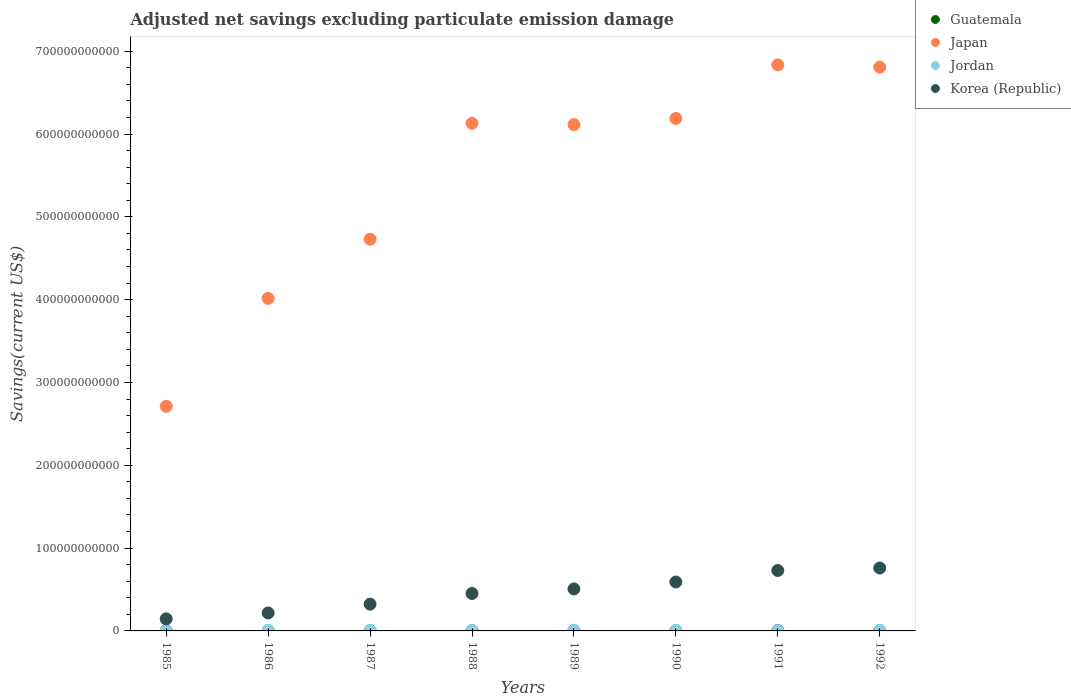Is the number of dotlines equal to the number of legend labels?
Your answer should be compact. Yes. What is the adjusted net savings in Guatemala in 1985?
Give a very brief answer. 2.18e+08. Across all years, what is the maximum adjusted net savings in Japan?
Keep it short and to the point. 6.84e+11. Across all years, what is the minimum adjusted net savings in Jordan?
Make the answer very short. 3.53e+08. What is the total adjusted net savings in Guatemala in the graph?
Your answer should be compact. 1.86e+09. What is the difference between the adjusted net savings in Japan in 1985 and that in 1990?
Give a very brief answer. -3.48e+11. What is the difference between the adjusted net savings in Guatemala in 1985 and the adjusted net savings in Jordan in 1986?
Offer a terse response. -4.72e+08. What is the average adjusted net savings in Japan per year?
Your response must be concise. 5.44e+11. In the year 1989, what is the difference between the adjusted net savings in Jordan and adjusted net savings in Guatemala?
Keep it short and to the point. 6.86e+08. In how many years, is the adjusted net savings in Korea (Republic) greater than 280000000000 US$?
Your answer should be very brief. 0. What is the ratio of the adjusted net savings in Jordan in 1986 to that in 1989?
Provide a short and direct response. 0.73. Is the difference between the adjusted net savings in Jordan in 1985 and 1988 greater than the difference between the adjusted net savings in Guatemala in 1985 and 1988?
Your answer should be compact. No. What is the difference between the highest and the second highest adjusted net savings in Korea (Republic)?
Give a very brief answer. 3.00e+09. What is the difference between the highest and the lowest adjusted net savings in Guatemala?
Your response must be concise. 3.24e+08. Is it the case that in every year, the sum of the adjusted net savings in Japan and adjusted net savings in Guatemala  is greater than the sum of adjusted net savings in Korea (Republic) and adjusted net savings in Jordan?
Offer a terse response. Yes. Does the adjusted net savings in Japan monotonically increase over the years?
Your answer should be very brief. No. Is the adjusted net savings in Korea (Republic) strictly greater than the adjusted net savings in Jordan over the years?
Your response must be concise. Yes. Is the adjusted net savings in Korea (Republic) strictly less than the adjusted net savings in Jordan over the years?
Make the answer very short. No. How many years are there in the graph?
Your answer should be very brief. 8. What is the difference between two consecutive major ticks on the Y-axis?
Give a very brief answer. 1.00e+11. Are the values on the major ticks of Y-axis written in scientific E-notation?
Provide a succinct answer. No. Does the graph contain grids?
Make the answer very short. No. How are the legend labels stacked?
Your answer should be very brief. Vertical. What is the title of the graph?
Ensure brevity in your answer.  Adjusted net savings excluding particulate emission damage. What is the label or title of the Y-axis?
Give a very brief answer. Savings(current US$). What is the Savings(current US$) of Guatemala in 1985?
Provide a succinct answer. 2.18e+08. What is the Savings(current US$) of Japan in 1985?
Your answer should be very brief. 2.71e+11. What is the Savings(current US$) in Jordan in 1985?
Keep it short and to the point. 4.20e+08. What is the Savings(current US$) in Korea (Republic) in 1985?
Provide a short and direct response. 1.46e+1. What is the Savings(current US$) in Guatemala in 1986?
Provide a short and direct response. 2.37e+08. What is the Savings(current US$) in Japan in 1986?
Make the answer very short. 4.02e+11. What is the Savings(current US$) of Jordan in 1986?
Offer a very short reply. 6.90e+08. What is the Savings(current US$) in Korea (Republic) in 1986?
Your answer should be very brief. 2.17e+1. What is the Savings(current US$) of Guatemala in 1987?
Provide a short and direct response. 7.49e+07. What is the Savings(current US$) in Japan in 1987?
Your response must be concise. 4.73e+11. What is the Savings(current US$) of Jordan in 1987?
Provide a short and direct response. 5.22e+08. What is the Savings(current US$) of Korea (Republic) in 1987?
Your answer should be compact. 3.23e+1. What is the Savings(current US$) of Guatemala in 1988?
Ensure brevity in your answer.  1.57e+08. What is the Savings(current US$) in Japan in 1988?
Keep it short and to the point. 6.13e+11. What is the Savings(current US$) in Jordan in 1988?
Make the answer very short. 7.16e+08. What is the Savings(current US$) in Korea (Republic) in 1988?
Your answer should be compact. 4.52e+1. What is the Savings(current US$) of Guatemala in 1989?
Keep it short and to the point. 2.54e+08. What is the Savings(current US$) of Japan in 1989?
Make the answer very short. 6.11e+11. What is the Savings(current US$) in Jordan in 1989?
Your answer should be compact. 9.40e+08. What is the Savings(current US$) of Korea (Republic) in 1989?
Provide a short and direct response. 5.07e+1. What is the Savings(current US$) in Guatemala in 1990?
Give a very brief answer. 1.51e+08. What is the Savings(current US$) in Japan in 1990?
Make the answer very short. 6.19e+11. What is the Savings(current US$) in Jordan in 1990?
Offer a terse response. 6.75e+08. What is the Savings(current US$) in Korea (Republic) in 1990?
Your answer should be compact. 5.91e+1. What is the Savings(current US$) in Guatemala in 1991?
Keep it short and to the point. 3.66e+08. What is the Savings(current US$) in Japan in 1991?
Provide a succinct answer. 6.84e+11. What is the Savings(current US$) in Jordan in 1991?
Offer a very short reply. 3.53e+08. What is the Savings(current US$) of Korea (Republic) in 1991?
Your answer should be compact. 7.30e+1. What is the Savings(current US$) of Guatemala in 1992?
Your answer should be very brief. 3.99e+08. What is the Savings(current US$) of Japan in 1992?
Offer a terse response. 6.81e+11. What is the Savings(current US$) in Jordan in 1992?
Keep it short and to the point. 6.44e+08. What is the Savings(current US$) of Korea (Republic) in 1992?
Your answer should be compact. 7.60e+1. Across all years, what is the maximum Savings(current US$) of Guatemala?
Your answer should be very brief. 3.99e+08. Across all years, what is the maximum Savings(current US$) in Japan?
Your answer should be very brief. 6.84e+11. Across all years, what is the maximum Savings(current US$) in Jordan?
Provide a succinct answer. 9.40e+08. Across all years, what is the maximum Savings(current US$) in Korea (Republic)?
Keep it short and to the point. 7.60e+1. Across all years, what is the minimum Savings(current US$) in Guatemala?
Provide a short and direct response. 7.49e+07. Across all years, what is the minimum Savings(current US$) in Japan?
Give a very brief answer. 2.71e+11. Across all years, what is the minimum Savings(current US$) in Jordan?
Make the answer very short. 3.53e+08. Across all years, what is the minimum Savings(current US$) in Korea (Republic)?
Make the answer very short. 1.46e+1. What is the total Savings(current US$) of Guatemala in the graph?
Give a very brief answer. 1.86e+09. What is the total Savings(current US$) of Japan in the graph?
Provide a succinct answer. 4.35e+12. What is the total Savings(current US$) of Jordan in the graph?
Make the answer very short. 4.96e+09. What is the total Savings(current US$) in Korea (Republic) in the graph?
Offer a terse response. 3.73e+11. What is the difference between the Savings(current US$) in Guatemala in 1985 and that in 1986?
Keep it short and to the point. -1.93e+07. What is the difference between the Savings(current US$) of Japan in 1985 and that in 1986?
Your answer should be very brief. -1.30e+11. What is the difference between the Savings(current US$) of Jordan in 1985 and that in 1986?
Offer a terse response. -2.70e+08. What is the difference between the Savings(current US$) in Korea (Republic) in 1985 and that in 1986?
Your answer should be compact. -7.15e+09. What is the difference between the Savings(current US$) in Guatemala in 1985 and that in 1987?
Make the answer very short. 1.43e+08. What is the difference between the Savings(current US$) of Japan in 1985 and that in 1987?
Keep it short and to the point. -2.02e+11. What is the difference between the Savings(current US$) of Jordan in 1985 and that in 1987?
Your answer should be compact. -1.02e+08. What is the difference between the Savings(current US$) in Korea (Republic) in 1985 and that in 1987?
Ensure brevity in your answer.  -1.78e+1. What is the difference between the Savings(current US$) in Guatemala in 1985 and that in 1988?
Provide a succinct answer. 6.14e+07. What is the difference between the Savings(current US$) in Japan in 1985 and that in 1988?
Ensure brevity in your answer.  -3.42e+11. What is the difference between the Savings(current US$) in Jordan in 1985 and that in 1988?
Provide a short and direct response. -2.96e+08. What is the difference between the Savings(current US$) in Korea (Republic) in 1985 and that in 1988?
Ensure brevity in your answer.  -3.06e+1. What is the difference between the Savings(current US$) of Guatemala in 1985 and that in 1989?
Make the answer very short. -3.58e+07. What is the difference between the Savings(current US$) of Japan in 1985 and that in 1989?
Offer a terse response. -3.40e+11. What is the difference between the Savings(current US$) of Jordan in 1985 and that in 1989?
Your answer should be compact. -5.20e+08. What is the difference between the Savings(current US$) in Korea (Republic) in 1985 and that in 1989?
Ensure brevity in your answer.  -3.62e+1. What is the difference between the Savings(current US$) in Guatemala in 1985 and that in 1990?
Keep it short and to the point. 6.65e+07. What is the difference between the Savings(current US$) in Japan in 1985 and that in 1990?
Provide a succinct answer. -3.48e+11. What is the difference between the Savings(current US$) in Jordan in 1985 and that in 1990?
Your response must be concise. -2.55e+08. What is the difference between the Savings(current US$) in Korea (Republic) in 1985 and that in 1990?
Offer a terse response. -4.45e+1. What is the difference between the Savings(current US$) of Guatemala in 1985 and that in 1991?
Offer a very short reply. -1.49e+08. What is the difference between the Savings(current US$) in Japan in 1985 and that in 1991?
Keep it short and to the point. -4.12e+11. What is the difference between the Savings(current US$) of Jordan in 1985 and that in 1991?
Offer a terse response. 6.69e+07. What is the difference between the Savings(current US$) of Korea (Republic) in 1985 and that in 1991?
Provide a short and direct response. -5.84e+1. What is the difference between the Savings(current US$) of Guatemala in 1985 and that in 1992?
Keep it short and to the point. -1.81e+08. What is the difference between the Savings(current US$) in Japan in 1985 and that in 1992?
Provide a succinct answer. -4.10e+11. What is the difference between the Savings(current US$) in Jordan in 1985 and that in 1992?
Your response must be concise. -2.24e+08. What is the difference between the Savings(current US$) in Korea (Republic) in 1985 and that in 1992?
Make the answer very short. -6.14e+1. What is the difference between the Savings(current US$) in Guatemala in 1986 and that in 1987?
Your answer should be very brief. 1.62e+08. What is the difference between the Savings(current US$) in Japan in 1986 and that in 1987?
Offer a terse response. -7.14e+1. What is the difference between the Savings(current US$) of Jordan in 1986 and that in 1987?
Make the answer very short. 1.68e+08. What is the difference between the Savings(current US$) in Korea (Republic) in 1986 and that in 1987?
Provide a succinct answer. -1.06e+1. What is the difference between the Savings(current US$) in Guatemala in 1986 and that in 1988?
Give a very brief answer. 8.06e+07. What is the difference between the Savings(current US$) in Japan in 1986 and that in 1988?
Make the answer very short. -2.11e+11. What is the difference between the Savings(current US$) in Jordan in 1986 and that in 1988?
Ensure brevity in your answer.  -2.52e+07. What is the difference between the Savings(current US$) of Korea (Republic) in 1986 and that in 1988?
Give a very brief answer. -2.35e+1. What is the difference between the Savings(current US$) of Guatemala in 1986 and that in 1989?
Your response must be concise. -1.65e+07. What is the difference between the Savings(current US$) of Japan in 1986 and that in 1989?
Your answer should be compact. -2.10e+11. What is the difference between the Savings(current US$) of Jordan in 1986 and that in 1989?
Your answer should be very brief. -2.49e+08. What is the difference between the Savings(current US$) in Korea (Republic) in 1986 and that in 1989?
Ensure brevity in your answer.  -2.90e+1. What is the difference between the Savings(current US$) of Guatemala in 1986 and that in 1990?
Ensure brevity in your answer.  8.58e+07. What is the difference between the Savings(current US$) in Japan in 1986 and that in 1990?
Give a very brief answer. -2.17e+11. What is the difference between the Savings(current US$) in Jordan in 1986 and that in 1990?
Give a very brief answer. 1.50e+07. What is the difference between the Savings(current US$) in Korea (Republic) in 1986 and that in 1990?
Ensure brevity in your answer.  -3.74e+1. What is the difference between the Savings(current US$) in Guatemala in 1986 and that in 1991?
Ensure brevity in your answer.  -1.29e+08. What is the difference between the Savings(current US$) of Japan in 1986 and that in 1991?
Provide a succinct answer. -2.82e+11. What is the difference between the Savings(current US$) of Jordan in 1986 and that in 1991?
Offer a terse response. 3.37e+08. What is the difference between the Savings(current US$) in Korea (Republic) in 1986 and that in 1991?
Give a very brief answer. -5.12e+1. What is the difference between the Savings(current US$) of Guatemala in 1986 and that in 1992?
Your answer should be very brief. -1.62e+08. What is the difference between the Savings(current US$) in Japan in 1986 and that in 1992?
Make the answer very short. -2.79e+11. What is the difference between the Savings(current US$) of Jordan in 1986 and that in 1992?
Your response must be concise. 4.66e+07. What is the difference between the Savings(current US$) in Korea (Republic) in 1986 and that in 1992?
Keep it short and to the point. -5.43e+1. What is the difference between the Savings(current US$) in Guatemala in 1987 and that in 1988?
Offer a very short reply. -8.17e+07. What is the difference between the Savings(current US$) of Japan in 1987 and that in 1988?
Provide a succinct answer. -1.40e+11. What is the difference between the Savings(current US$) of Jordan in 1987 and that in 1988?
Your answer should be very brief. -1.93e+08. What is the difference between the Savings(current US$) of Korea (Republic) in 1987 and that in 1988?
Your answer should be compact. -1.28e+1. What is the difference between the Savings(current US$) of Guatemala in 1987 and that in 1989?
Make the answer very short. -1.79e+08. What is the difference between the Savings(current US$) in Japan in 1987 and that in 1989?
Your answer should be very brief. -1.38e+11. What is the difference between the Savings(current US$) of Jordan in 1987 and that in 1989?
Give a very brief answer. -4.17e+08. What is the difference between the Savings(current US$) of Korea (Republic) in 1987 and that in 1989?
Provide a short and direct response. -1.84e+1. What is the difference between the Savings(current US$) in Guatemala in 1987 and that in 1990?
Offer a very short reply. -7.65e+07. What is the difference between the Savings(current US$) in Japan in 1987 and that in 1990?
Provide a short and direct response. -1.46e+11. What is the difference between the Savings(current US$) in Jordan in 1987 and that in 1990?
Provide a succinct answer. -1.53e+08. What is the difference between the Savings(current US$) in Korea (Republic) in 1987 and that in 1990?
Your response must be concise. -2.67e+1. What is the difference between the Savings(current US$) of Guatemala in 1987 and that in 1991?
Give a very brief answer. -2.92e+08. What is the difference between the Savings(current US$) in Japan in 1987 and that in 1991?
Ensure brevity in your answer.  -2.11e+11. What is the difference between the Savings(current US$) in Jordan in 1987 and that in 1991?
Offer a terse response. 1.69e+08. What is the difference between the Savings(current US$) of Korea (Republic) in 1987 and that in 1991?
Your response must be concise. -4.06e+1. What is the difference between the Savings(current US$) in Guatemala in 1987 and that in 1992?
Give a very brief answer. -3.24e+08. What is the difference between the Savings(current US$) in Japan in 1987 and that in 1992?
Your response must be concise. -2.08e+11. What is the difference between the Savings(current US$) in Jordan in 1987 and that in 1992?
Offer a very short reply. -1.21e+08. What is the difference between the Savings(current US$) in Korea (Republic) in 1987 and that in 1992?
Ensure brevity in your answer.  -4.36e+1. What is the difference between the Savings(current US$) of Guatemala in 1988 and that in 1989?
Give a very brief answer. -9.71e+07. What is the difference between the Savings(current US$) in Japan in 1988 and that in 1989?
Give a very brief answer. 1.54e+09. What is the difference between the Savings(current US$) of Jordan in 1988 and that in 1989?
Give a very brief answer. -2.24e+08. What is the difference between the Savings(current US$) of Korea (Republic) in 1988 and that in 1989?
Your answer should be very brief. -5.55e+09. What is the difference between the Savings(current US$) of Guatemala in 1988 and that in 1990?
Provide a succinct answer. 5.14e+06. What is the difference between the Savings(current US$) in Japan in 1988 and that in 1990?
Give a very brief answer. -5.89e+09. What is the difference between the Savings(current US$) in Jordan in 1988 and that in 1990?
Make the answer very short. 4.03e+07. What is the difference between the Savings(current US$) in Korea (Republic) in 1988 and that in 1990?
Your response must be concise. -1.39e+1. What is the difference between the Savings(current US$) of Guatemala in 1988 and that in 1991?
Offer a terse response. -2.10e+08. What is the difference between the Savings(current US$) in Japan in 1988 and that in 1991?
Your response must be concise. -7.06e+1. What is the difference between the Savings(current US$) of Jordan in 1988 and that in 1991?
Your response must be concise. 3.63e+08. What is the difference between the Savings(current US$) of Korea (Republic) in 1988 and that in 1991?
Keep it short and to the point. -2.78e+1. What is the difference between the Savings(current US$) of Guatemala in 1988 and that in 1992?
Provide a short and direct response. -2.42e+08. What is the difference between the Savings(current US$) of Japan in 1988 and that in 1992?
Offer a terse response. -6.78e+1. What is the difference between the Savings(current US$) in Jordan in 1988 and that in 1992?
Keep it short and to the point. 7.18e+07. What is the difference between the Savings(current US$) of Korea (Republic) in 1988 and that in 1992?
Your answer should be compact. -3.08e+1. What is the difference between the Savings(current US$) of Guatemala in 1989 and that in 1990?
Ensure brevity in your answer.  1.02e+08. What is the difference between the Savings(current US$) in Japan in 1989 and that in 1990?
Your answer should be compact. -7.42e+09. What is the difference between the Savings(current US$) in Jordan in 1989 and that in 1990?
Offer a very short reply. 2.64e+08. What is the difference between the Savings(current US$) in Korea (Republic) in 1989 and that in 1990?
Your answer should be very brief. -8.37e+09. What is the difference between the Savings(current US$) of Guatemala in 1989 and that in 1991?
Keep it short and to the point. -1.13e+08. What is the difference between the Savings(current US$) of Japan in 1989 and that in 1991?
Offer a very short reply. -7.21e+1. What is the difference between the Savings(current US$) of Jordan in 1989 and that in 1991?
Make the answer very short. 5.87e+08. What is the difference between the Savings(current US$) in Korea (Republic) in 1989 and that in 1991?
Make the answer very short. -2.22e+1. What is the difference between the Savings(current US$) in Guatemala in 1989 and that in 1992?
Offer a terse response. -1.45e+08. What is the difference between the Savings(current US$) in Japan in 1989 and that in 1992?
Your response must be concise. -6.94e+1. What is the difference between the Savings(current US$) in Jordan in 1989 and that in 1992?
Make the answer very short. 2.96e+08. What is the difference between the Savings(current US$) in Korea (Republic) in 1989 and that in 1992?
Provide a short and direct response. -2.52e+1. What is the difference between the Savings(current US$) of Guatemala in 1990 and that in 1991?
Give a very brief answer. -2.15e+08. What is the difference between the Savings(current US$) in Japan in 1990 and that in 1991?
Your answer should be very brief. -6.47e+1. What is the difference between the Savings(current US$) in Jordan in 1990 and that in 1991?
Ensure brevity in your answer.  3.22e+08. What is the difference between the Savings(current US$) of Korea (Republic) in 1990 and that in 1991?
Give a very brief answer. -1.39e+1. What is the difference between the Savings(current US$) in Guatemala in 1990 and that in 1992?
Give a very brief answer. -2.48e+08. What is the difference between the Savings(current US$) of Japan in 1990 and that in 1992?
Your answer should be very brief. -6.19e+1. What is the difference between the Savings(current US$) of Jordan in 1990 and that in 1992?
Keep it short and to the point. 3.15e+07. What is the difference between the Savings(current US$) of Korea (Republic) in 1990 and that in 1992?
Offer a terse response. -1.69e+1. What is the difference between the Savings(current US$) of Guatemala in 1991 and that in 1992?
Keep it short and to the point. -3.26e+07. What is the difference between the Savings(current US$) of Japan in 1991 and that in 1992?
Offer a terse response. 2.75e+09. What is the difference between the Savings(current US$) in Jordan in 1991 and that in 1992?
Offer a terse response. -2.91e+08. What is the difference between the Savings(current US$) of Korea (Republic) in 1991 and that in 1992?
Provide a short and direct response. -3.00e+09. What is the difference between the Savings(current US$) of Guatemala in 1985 and the Savings(current US$) of Japan in 1986?
Offer a very short reply. -4.01e+11. What is the difference between the Savings(current US$) of Guatemala in 1985 and the Savings(current US$) of Jordan in 1986?
Your answer should be compact. -4.72e+08. What is the difference between the Savings(current US$) in Guatemala in 1985 and the Savings(current US$) in Korea (Republic) in 1986?
Give a very brief answer. -2.15e+1. What is the difference between the Savings(current US$) in Japan in 1985 and the Savings(current US$) in Jordan in 1986?
Ensure brevity in your answer.  2.71e+11. What is the difference between the Savings(current US$) of Japan in 1985 and the Savings(current US$) of Korea (Republic) in 1986?
Offer a terse response. 2.49e+11. What is the difference between the Savings(current US$) of Jordan in 1985 and the Savings(current US$) of Korea (Republic) in 1986?
Give a very brief answer. -2.13e+1. What is the difference between the Savings(current US$) of Guatemala in 1985 and the Savings(current US$) of Japan in 1987?
Offer a terse response. -4.73e+11. What is the difference between the Savings(current US$) in Guatemala in 1985 and the Savings(current US$) in Jordan in 1987?
Your answer should be very brief. -3.04e+08. What is the difference between the Savings(current US$) in Guatemala in 1985 and the Savings(current US$) in Korea (Republic) in 1987?
Ensure brevity in your answer.  -3.21e+1. What is the difference between the Savings(current US$) in Japan in 1985 and the Savings(current US$) in Jordan in 1987?
Offer a terse response. 2.71e+11. What is the difference between the Savings(current US$) of Japan in 1985 and the Savings(current US$) of Korea (Republic) in 1987?
Keep it short and to the point. 2.39e+11. What is the difference between the Savings(current US$) in Jordan in 1985 and the Savings(current US$) in Korea (Republic) in 1987?
Offer a terse response. -3.19e+1. What is the difference between the Savings(current US$) of Guatemala in 1985 and the Savings(current US$) of Japan in 1988?
Your answer should be compact. -6.13e+11. What is the difference between the Savings(current US$) in Guatemala in 1985 and the Savings(current US$) in Jordan in 1988?
Offer a terse response. -4.98e+08. What is the difference between the Savings(current US$) of Guatemala in 1985 and the Savings(current US$) of Korea (Republic) in 1988?
Offer a very short reply. -4.50e+1. What is the difference between the Savings(current US$) in Japan in 1985 and the Savings(current US$) in Jordan in 1988?
Provide a succinct answer. 2.70e+11. What is the difference between the Savings(current US$) of Japan in 1985 and the Savings(current US$) of Korea (Republic) in 1988?
Keep it short and to the point. 2.26e+11. What is the difference between the Savings(current US$) of Jordan in 1985 and the Savings(current US$) of Korea (Republic) in 1988?
Give a very brief answer. -4.48e+1. What is the difference between the Savings(current US$) in Guatemala in 1985 and the Savings(current US$) in Japan in 1989?
Your answer should be compact. -6.11e+11. What is the difference between the Savings(current US$) in Guatemala in 1985 and the Savings(current US$) in Jordan in 1989?
Offer a very short reply. -7.22e+08. What is the difference between the Savings(current US$) in Guatemala in 1985 and the Savings(current US$) in Korea (Republic) in 1989?
Keep it short and to the point. -5.05e+1. What is the difference between the Savings(current US$) in Japan in 1985 and the Savings(current US$) in Jordan in 1989?
Provide a succinct answer. 2.70e+11. What is the difference between the Savings(current US$) of Japan in 1985 and the Savings(current US$) of Korea (Republic) in 1989?
Your response must be concise. 2.20e+11. What is the difference between the Savings(current US$) in Jordan in 1985 and the Savings(current US$) in Korea (Republic) in 1989?
Your answer should be very brief. -5.03e+1. What is the difference between the Savings(current US$) of Guatemala in 1985 and the Savings(current US$) of Japan in 1990?
Your answer should be very brief. -6.19e+11. What is the difference between the Savings(current US$) in Guatemala in 1985 and the Savings(current US$) in Jordan in 1990?
Offer a terse response. -4.57e+08. What is the difference between the Savings(current US$) in Guatemala in 1985 and the Savings(current US$) in Korea (Republic) in 1990?
Give a very brief answer. -5.89e+1. What is the difference between the Savings(current US$) of Japan in 1985 and the Savings(current US$) of Jordan in 1990?
Ensure brevity in your answer.  2.71e+11. What is the difference between the Savings(current US$) in Japan in 1985 and the Savings(current US$) in Korea (Republic) in 1990?
Provide a succinct answer. 2.12e+11. What is the difference between the Savings(current US$) of Jordan in 1985 and the Savings(current US$) of Korea (Republic) in 1990?
Make the answer very short. -5.87e+1. What is the difference between the Savings(current US$) in Guatemala in 1985 and the Savings(current US$) in Japan in 1991?
Your answer should be very brief. -6.83e+11. What is the difference between the Savings(current US$) in Guatemala in 1985 and the Savings(current US$) in Jordan in 1991?
Provide a succinct answer. -1.35e+08. What is the difference between the Savings(current US$) in Guatemala in 1985 and the Savings(current US$) in Korea (Republic) in 1991?
Provide a succinct answer. -7.27e+1. What is the difference between the Savings(current US$) in Japan in 1985 and the Savings(current US$) in Jordan in 1991?
Your answer should be compact. 2.71e+11. What is the difference between the Savings(current US$) of Japan in 1985 and the Savings(current US$) of Korea (Republic) in 1991?
Make the answer very short. 1.98e+11. What is the difference between the Savings(current US$) of Jordan in 1985 and the Savings(current US$) of Korea (Republic) in 1991?
Keep it short and to the point. -7.25e+1. What is the difference between the Savings(current US$) of Guatemala in 1985 and the Savings(current US$) of Japan in 1992?
Give a very brief answer. -6.81e+11. What is the difference between the Savings(current US$) of Guatemala in 1985 and the Savings(current US$) of Jordan in 1992?
Keep it short and to the point. -4.26e+08. What is the difference between the Savings(current US$) in Guatemala in 1985 and the Savings(current US$) in Korea (Republic) in 1992?
Make the answer very short. -7.57e+1. What is the difference between the Savings(current US$) in Japan in 1985 and the Savings(current US$) in Jordan in 1992?
Provide a short and direct response. 2.71e+11. What is the difference between the Savings(current US$) of Japan in 1985 and the Savings(current US$) of Korea (Republic) in 1992?
Provide a short and direct response. 1.95e+11. What is the difference between the Savings(current US$) of Jordan in 1985 and the Savings(current US$) of Korea (Republic) in 1992?
Give a very brief answer. -7.55e+1. What is the difference between the Savings(current US$) of Guatemala in 1986 and the Savings(current US$) of Japan in 1987?
Provide a short and direct response. -4.73e+11. What is the difference between the Savings(current US$) of Guatemala in 1986 and the Savings(current US$) of Jordan in 1987?
Offer a very short reply. -2.85e+08. What is the difference between the Savings(current US$) of Guatemala in 1986 and the Savings(current US$) of Korea (Republic) in 1987?
Keep it short and to the point. -3.21e+1. What is the difference between the Savings(current US$) in Japan in 1986 and the Savings(current US$) in Jordan in 1987?
Offer a very short reply. 4.01e+11. What is the difference between the Savings(current US$) of Japan in 1986 and the Savings(current US$) of Korea (Republic) in 1987?
Keep it short and to the point. 3.69e+11. What is the difference between the Savings(current US$) of Jordan in 1986 and the Savings(current US$) of Korea (Republic) in 1987?
Your response must be concise. -3.17e+1. What is the difference between the Savings(current US$) of Guatemala in 1986 and the Savings(current US$) of Japan in 1988?
Make the answer very short. -6.13e+11. What is the difference between the Savings(current US$) in Guatemala in 1986 and the Savings(current US$) in Jordan in 1988?
Ensure brevity in your answer.  -4.78e+08. What is the difference between the Savings(current US$) of Guatemala in 1986 and the Savings(current US$) of Korea (Republic) in 1988?
Your answer should be very brief. -4.49e+1. What is the difference between the Savings(current US$) in Japan in 1986 and the Savings(current US$) in Jordan in 1988?
Provide a succinct answer. 4.01e+11. What is the difference between the Savings(current US$) of Japan in 1986 and the Savings(current US$) of Korea (Republic) in 1988?
Provide a succinct answer. 3.56e+11. What is the difference between the Savings(current US$) of Jordan in 1986 and the Savings(current US$) of Korea (Republic) in 1988?
Give a very brief answer. -4.45e+1. What is the difference between the Savings(current US$) of Guatemala in 1986 and the Savings(current US$) of Japan in 1989?
Offer a very short reply. -6.11e+11. What is the difference between the Savings(current US$) of Guatemala in 1986 and the Savings(current US$) of Jordan in 1989?
Your answer should be compact. -7.03e+08. What is the difference between the Savings(current US$) in Guatemala in 1986 and the Savings(current US$) in Korea (Republic) in 1989?
Your answer should be very brief. -5.05e+1. What is the difference between the Savings(current US$) in Japan in 1986 and the Savings(current US$) in Jordan in 1989?
Your answer should be compact. 4.01e+11. What is the difference between the Savings(current US$) in Japan in 1986 and the Savings(current US$) in Korea (Republic) in 1989?
Make the answer very short. 3.51e+11. What is the difference between the Savings(current US$) of Jordan in 1986 and the Savings(current US$) of Korea (Republic) in 1989?
Keep it short and to the point. -5.00e+1. What is the difference between the Savings(current US$) of Guatemala in 1986 and the Savings(current US$) of Japan in 1990?
Ensure brevity in your answer.  -6.19e+11. What is the difference between the Savings(current US$) of Guatemala in 1986 and the Savings(current US$) of Jordan in 1990?
Your response must be concise. -4.38e+08. What is the difference between the Savings(current US$) of Guatemala in 1986 and the Savings(current US$) of Korea (Republic) in 1990?
Your answer should be compact. -5.89e+1. What is the difference between the Savings(current US$) in Japan in 1986 and the Savings(current US$) in Jordan in 1990?
Keep it short and to the point. 4.01e+11. What is the difference between the Savings(current US$) in Japan in 1986 and the Savings(current US$) in Korea (Republic) in 1990?
Keep it short and to the point. 3.42e+11. What is the difference between the Savings(current US$) in Jordan in 1986 and the Savings(current US$) in Korea (Republic) in 1990?
Offer a very short reply. -5.84e+1. What is the difference between the Savings(current US$) of Guatemala in 1986 and the Savings(current US$) of Japan in 1991?
Give a very brief answer. -6.83e+11. What is the difference between the Savings(current US$) in Guatemala in 1986 and the Savings(current US$) in Jordan in 1991?
Ensure brevity in your answer.  -1.16e+08. What is the difference between the Savings(current US$) of Guatemala in 1986 and the Savings(current US$) of Korea (Republic) in 1991?
Provide a short and direct response. -7.27e+1. What is the difference between the Savings(current US$) of Japan in 1986 and the Savings(current US$) of Jordan in 1991?
Provide a short and direct response. 4.01e+11. What is the difference between the Savings(current US$) in Japan in 1986 and the Savings(current US$) in Korea (Republic) in 1991?
Provide a succinct answer. 3.29e+11. What is the difference between the Savings(current US$) of Jordan in 1986 and the Savings(current US$) of Korea (Republic) in 1991?
Provide a succinct answer. -7.23e+1. What is the difference between the Savings(current US$) of Guatemala in 1986 and the Savings(current US$) of Japan in 1992?
Offer a terse response. -6.81e+11. What is the difference between the Savings(current US$) of Guatemala in 1986 and the Savings(current US$) of Jordan in 1992?
Offer a terse response. -4.07e+08. What is the difference between the Savings(current US$) of Guatemala in 1986 and the Savings(current US$) of Korea (Republic) in 1992?
Ensure brevity in your answer.  -7.57e+1. What is the difference between the Savings(current US$) in Japan in 1986 and the Savings(current US$) in Jordan in 1992?
Keep it short and to the point. 4.01e+11. What is the difference between the Savings(current US$) of Japan in 1986 and the Savings(current US$) of Korea (Republic) in 1992?
Your response must be concise. 3.26e+11. What is the difference between the Savings(current US$) in Jordan in 1986 and the Savings(current US$) in Korea (Republic) in 1992?
Your answer should be very brief. -7.53e+1. What is the difference between the Savings(current US$) in Guatemala in 1987 and the Savings(current US$) in Japan in 1988?
Ensure brevity in your answer.  -6.13e+11. What is the difference between the Savings(current US$) of Guatemala in 1987 and the Savings(current US$) of Jordan in 1988?
Ensure brevity in your answer.  -6.41e+08. What is the difference between the Savings(current US$) in Guatemala in 1987 and the Savings(current US$) in Korea (Republic) in 1988?
Your answer should be compact. -4.51e+1. What is the difference between the Savings(current US$) of Japan in 1987 and the Savings(current US$) of Jordan in 1988?
Ensure brevity in your answer.  4.72e+11. What is the difference between the Savings(current US$) in Japan in 1987 and the Savings(current US$) in Korea (Republic) in 1988?
Keep it short and to the point. 4.28e+11. What is the difference between the Savings(current US$) of Jordan in 1987 and the Savings(current US$) of Korea (Republic) in 1988?
Provide a succinct answer. -4.47e+1. What is the difference between the Savings(current US$) of Guatemala in 1987 and the Savings(current US$) of Japan in 1989?
Your response must be concise. -6.11e+11. What is the difference between the Savings(current US$) of Guatemala in 1987 and the Savings(current US$) of Jordan in 1989?
Provide a short and direct response. -8.65e+08. What is the difference between the Savings(current US$) of Guatemala in 1987 and the Savings(current US$) of Korea (Republic) in 1989?
Make the answer very short. -5.07e+1. What is the difference between the Savings(current US$) in Japan in 1987 and the Savings(current US$) in Jordan in 1989?
Provide a succinct answer. 4.72e+11. What is the difference between the Savings(current US$) of Japan in 1987 and the Savings(current US$) of Korea (Republic) in 1989?
Provide a succinct answer. 4.22e+11. What is the difference between the Savings(current US$) in Jordan in 1987 and the Savings(current US$) in Korea (Republic) in 1989?
Make the answer very short. -5.02e+1. What is the difference between the Savings(current US$) of Guatemala in 1987 and the Savings(current US$) of Japan in 1990?
Keep it short and to the point. -6.19e+11. What is the difference between the Savings(current US$) in Guatemala in 1987 and the Savings(current US$) in Jordan in 1990?
Your answer should be very brief. -6.00e+08. What is the difference between the Savings(current US$) of Guatemala in 1987 and the Savings(current US$) of Korea (Republic) in 1990?
Make the answer very short. -5.90e+1. What is the difference between the Savings(current US$) in Japan in 1987 and the Savings(current US$) in Jordan in 1990?
Your answer should be compact. 4.72e+11. What is the difference between the Savings(current US$) of Japan in 1987 and the Savings(current US$) of Korea (Republic) in 1990?
Your answer should be very brief. 4.14e+11. What is the difference between the Savings(current US$) in Jordan in 1987 and the Savings(current US$) in Korea (Republic) in 1990?
Your response must be concise. -5.86e+1. What is the difference between the Savings(current US$) of Guatemala in 1987 and the Savings(current US$) of Japan in 1991?
Your answer should be compact. -6.83e+11. What is the difference between the Savings(current US$) in Guatemala in 1987 and the Savings(current US$) in Jordan in 1991?
Offer a very short reply. -2.78e+08. What is the difference between the Savings(current US$) of Guatemala in 1987 and the Savings(current US$) of Korea (Republic) in 1991?
Ensure brevity in your answer.  -7.29e+1. What is the difference between the Savings(current US$) in Japan in 1987 and the Savings(current US$) in Jordan in 1991?
Offer a very short reply. 4.73e+11. What is the difference between the Savings(current US$) in Japan in 1987 and the Savings(current US$) in Korea (Republic) in 1991?
Provide a short and direct response. 4.00e+11. What is the difference between the Savings(current US$) in Jordan in 1987 and the Savings(current US$) in Korea (Republic) in 1991?
Offer a terse response. -7.24e+1. What is the difference between the Savings(current US$) of Guatemala in 1987 and the Savings(current US$) of Japan in 1992?
Your answer should be compact. -6.81e+11. What is the difference between the Savings(current US$) of Guatemala in 1987 and the Savings(current US$) of Jordan in 1992?
Provide a short and direct response. -5.69e+08. What is the difference between the Savings(current US$) of Guatemala in 1987 and the Savings(current US$) of Korea (Republic) in 1992?
Offer a very short reply. -7.59e+1. What is the difference between the Savings(current US$) in Japan in 1987 and the Savings(current US$) in Jordan in 1992?
Give a very brief answer. 4.72e+11. What is the difference between the Savings(current US$) in Japan in 1987 and the Savings(current US$) in Korea (Republic) in 1992?
Offer a very short reply. 3.97e+11. What is the difference between the Savings(current US$) in Jordan in 1987 and the Savings(current US$) in Korea (Republic) in 1992?
Provide a succinct answer. -7.54e+1. What is the difference between the Savings(current US$) of Guatemala in 1988 and the Savings(current US$) of Japan in 1989?
Your answer should be very brief. -6.11e+11. What is the difference between the Savings(current US$) in Guatemala in 1988 and the Savings(current US$) in Jordan in 1989?
Your answer should be compact. -7.83e+08. What is the difference between the Savings(current US$) of Guatemala in 1988 and the Savings(current US$) of Korea (Republic) in 1989?
Provide a short and direct response. -5.06e+1. What is the difference between the Savings(current US$) in Japan in 1988 and the Savings(current US$) in Jordan in 1989?
Give a very brief answer. 6.12e+11. What is the difference between the Savings(current US$) in Japan in 1988 and the Savings(current US$) in Korea (Republic) in 1989?
Offer a very short reply. 5.62e+11. What is the difference between the Savings(current US$) of Jordan in 1988 and the Savings(current US$) of Korea (Republic) in 1989?
Offer a very short reply. -5.00e+1. What is the difference between the Savings(current US$) of Guatemala in 1988 and the Savings(current US$) of Japan in 1990?
Offer a terse response. -6.19e+11. What is the difference between the Savings(current US$) in Guatemala in 1988 and the Savings(current US$) in Jordan in 1990?
Your response must be concise. -5.19e+08. What is the difference between the Savings(current US$) of Guatemala in 1988 and the Savings(current US$) of Korea (Republic) in 1990?
Offer a very short reply. -5.89e+1. What is the difference between the Savings(current US$) in Japan in 1988 and the Savings(current US$) in Jordan in 1990?
Your answer should be very brief. 6.12e+11. What is the difference between the Savings(current US$) of Japan in 1988 and the Savings(current US$) of Korea (Republic) in 1990?
Make the answer very short. 5.54e+11. What is the difference between the Savings(current US$) in Jordan in 1988 and the Savings(current US$) in Korea (Republic) in 1990?
Keep it short and to the point. -5.84e+1. What is the difference between the Savings(current US$) in Guatemala in 1988 and the Savings(current US$) in Japan in 1991?
Provide a succinct answer. -6.83e+11. What is the difference between the Savings(current US$) of Guatemala in 1988 and the Savings(current US$) of Jordan in 1991?
Keep it short and to the point. -1.96e+08. What is the difference between the Savings(current US$) in Guatemala in 1988 and the Savings(current US$) in Korea (Republic) in 1991?
Give a very brief answer. -7.28e+1. What is the difference between the Savings(current US$) in Japan in 1988 and the Savings(current US$) in Jordan in 1991?
Your response must be concise. 6.13e+11. What is the difference between the Savings(current US$) in Japan in 1988 and the Savings(current US$) in Korea (Republic) in 1991?
Provide a short and direct response. 5.40e+11. What is the difference between the Savings(current US$) in Jordan in 1988 and the Savings(current US$) in Korea (Republic) in 1991?
Your response must be concise. -7.22e+1. What is the difference between the Savings(current US$) in Guatemala in 1988 and the Savings(current US$) in Japan in 1992?
Your response must be concise. -6.81e+11. What is the difference between the Savings(current US$) of Guatemala in 1988 and the Savings(current US$) of Jordan in 1992?
Your answer should be compact. -4.87e+08. What is the difference between the Savings(current US$) of Guatemala in 1988 and the Savings(current US$) of Korea (Republic) in 1992?
Provide a short and direct response. -7.58e+1. What is the difference between the Savings(current US$) of Japan in 1988 and the Savings(current US$) of Jordan in 1992?
Your answer should be compact. 6.12e+11. What is the difference between the Savings(current US$) of Japan in 1988 and the Savings(current US$) of Korea (Republic) in 1992?
Provide a succinct answer. 5.37e+11. What is the difference between the Savings(current US$) of Jordan in 1988 and the Savings(current US$) of Korea (Republic) in 1992?
Keep it short and to the point. -7.52e+1. What is the difference between the Savings(current US$) in Guatemala in 1989 and the Savings(current US$) in Japan in 1990?
Give a very brief answer. -6.19e+11. What is the difference between the Savings(current US$) of Guatemala in 1989 and the Savings(current US$) of Jordan in 1990?
Provide a succinct answer. -4.22e+08. What is the difference between the Savings(current US$) of Guatemala in 1989 and the Savings(current US$) of Korea (Republic) in 1990?
Your answer should be very brief. -5.88e+1. What is the difference between the Savings(current US$) of Japan in 1989 and the Savings(current US$) of Jordan in 1990?
Provide a short and direct response. 6.11e+11. What is the difference between the Savings(current US$) of Japan in 1989 and the Savings(current US$) of Korea (Republic) in 1990?
Your answer should be compact. 5.52e+11. What is the difference between the Savings(current US$) of Jordan in 1989 and the Savings(current US$) of Korea (Republic) in 1990?
Your answer should be compact. -5.82e+1. What is the difference between the Savings(current US$) in Guatemala in 1989 and the Savings(current US$) in Japan in 1991?
Provide a short and direct response. -6.83e+11. What is the difference between the Savings(current US$) of Guatemala in 1989 and the Savings(current US$) of Jordan in 1991?
Give a very brief answer. -9.93e+07. What is the difference between the Savings(current US$) of Guatemala in 1989 and the Savings(current US$) of Korea (Republic) in 1991?
Keep it short and to the point. -7.27e+1. What is the difference between the Savings(current US$) of Japan in 1989 and the Savings(current US$) of Jordan in 1991?
Provide a short and direct response. 6.11e+11. What is the difference between the Savings(current US$) in Japan in 1989 and the Savings(current US$) in Korea (Republic) in 1991?
Offer a very short reply. 5.38e+11. What is the difference between the Savings(current US$) in Jordan in 1989 and the Savings(current US$) in Korea (Republic) in 1991?
Your response must be concise. -7.20e+1. What is the difference between the Savings(current US$) of Guatemala in 1989 and the Savings(current US$) of Japan in 1992?
Your answer should be compact. -6.81e+11. What is the difference between the Savings(current US$) in Guatemala in 1989 and the Savings(current US$) in Jordan in 1992?
Offer a terse response. -3.90e+08. What is the difference between the Savings(current US$) in Guatemala in 1989 and the Savings(current US$) in Korea (Republic) in 1992?
Keep it short and to the point. -7.57e+1. What is the difference between the Savings(current US$) of Japan in 1989 and the Savings(current US$) of Jordan in 1992?
Offer a very short reply. 6.11e+11. What is the difference between the Savings(current US$) in Japan in 1989 and the Savings(current US$) in Korea (Republic) in 1992?
Your answer should be very brief. 5.35e+11. What is the difference between the Savings(current US$) of Jordan in 1989 and the Savings(current US$) of Korea (Republic) in 1992?
Make the answer very short. -7.50e+1. What is the difference between the Savings(current US$) of Guatemala in 1990 and the Savings(current US$) of Japan in 1991?
Make the answer very short. -6.83e+11. What is the difference between the Savings(current US$) of Guatemala in 1990 and the Savings(current US$) of Jordan in 1991?
Your answer should be very brief. -2.02e+08. What is the difference between the Savings(current US$) in Guatemala in 1990 and the Savings(current US$) in Korea (Republic) in 1991?
Your answer should be very brief. -7.28e+1. What is the difference between the Savings(current US$) in Japan in 1990 and the Savings(current US$) in Jordan in 1991?
Provide a succinct answer. 6.18e+11. What is the difference between the Savings(current US$) of Japan in 1990 and the Savings(current US$) of Korea (Republic) in 1991?
Keep it short and to the point. 5.46e+11. What is the difference between the Savings(current US$) of Jordan in 1990 and the Savings(current US$) of Korea (Republic) in 1991?
Give a very brief answer. -7.23e+1. What is the difference between the Savings(current US$) in Guatemala in 1990 and the Savings(current US$) in Japan in 1992?
Make the answer very short. -6.81e+11. What is the difference between the Savings(current US$) of Guatemala in 1990 and the Savings(current US$) of Jordan in 1992?
Ensure brevity in your answer.  -4.92e+08. What is the difference between the Savings(current US$) of Guatemala in 1990 and the Savings(current US$) of Korea (Republic) in 1992?
Give a very brief answer. -7.58e+1. What is the difference between the Savings(current US$) in Japan in 1990 and the Savings(current US$) in Jordan in 1992?
Your answer should be very brief. 6.18e+11. What is the difference between the Savings(current US$) of Japan in 1990 and the Savings(current US$) of Korea (Republic) in 1992?
Your response must be concise. 5.43e+11. What is the difference between the Savings(current US$) of Jordan in 1990 and the Savings(current US$) of Korea (Republic) in 1992?
Your answer should be very brief. -7.53e+1. What is the difference between the Savings(current US$) in Guatemala in 1991 and the Savings(current US$) in Japan in 1992?
Provide a succinct answer. -6.80e+11. What is the difference between the Savings(current US$) in Guatemala in 1991 and the Savings(current US$) in Jordan in 1992?
Your answer should be very brief. -2.77e+08. What is the difference between the Savings(current US$) of Guatemala in 1991 and the Savings(current US$) of Korea (Republic) in 1992?
Give a very brief answer. -7.56e+1. What is the difference between the Savings(current US$) in Japan in 1991 and the Savings(current US$) in Jordan in 1992?
Offer a very short reply. 6.83e+11. What is the difference between the Savings(current US$) in Japan in 1991 and the Savings(current US$) in Korea (Republic) in 1992?
Provide a short and direct response. 6.08e+11. What is the difference between the Savings(current US$) of Jordan in 1991 and the Savings(current US$) of Korea (Republic) in 1992?
Provide a succinct answer. -7.56e+1. What is the average Savings(current US$) in Guatemala per year?
Ensure brevity in your answer.  2.32e+08. What is the average Savings(current US$) of Japan per year?
Your answer should be very brief. 5.44e+11. What is the average Savings(current US$) of Jordan per year?
Your response must be concise. 6.20e+08. What is the average Savings(current US$) of Korea (Republic) per year?
Your answer should be compact. 4.66e+1. In the year 1985, what is the difference between the Savings(current US$) in Guatemala and Savings(current US$) in Japan?
Your response must be concise. -2.71e+11. In the year 1985, what is the difference between the Savings(current US$) of Guatemala and Savings(current US$) of Jordan?
Make the answer very short. -2.02e+08. In the year 1985, what is the difference between the Savings(current US$) of Guatemala and Savings(current US$) of Korea (Republic)?
Keep it short and to the point. -1.44e+1. In the year 1985, what is the difference between the Savings(current US$) in Japan and Savings(current US$) in Jordan?
Offer a terse response. 2.71e+11. In the year 1985, what is the difference between the Savings(current US$) in Japan and Savings(current US$) in Korea (Republic)?
Your answer should be very brief. 2.57e+11. In the year 1985, what is the difference between the Savings(current US$) of Jordan and Savings(current US$) of Korea (Republic)?
Offer a very short reply. -1.41e+1. In the year 1986, what is the difference between the Savings(current US$) of Guatemala and Savings(current US$) of Japan?
Your answer should be compact. -4.01e+11. In the year 1986, what is the difference between the Savings(current US$) in Guatemala and Savings(current US$) in Jordan?
Give a very brief answer. -4.53e+08. In the year 1986, what is the difference between the Savings(current US$) in Guatemala and Savings(current US$) in Korea (Republic)?
Keep it short and to the point. -2.15e+1. In the year 1986, what is the difference between the Savings(current US$) of Japan and Savings(current US$) of Jordan?
Offer a very short reply. 4.01e+11. In the year 1986, what is the difference between the Savings(current US$) of Japan and Savings(current US$) of Korea (Republic)?
Your answer should be very brief. 3.80e+11. In the year 1986, what is the difference between the Savings(current US$) of Jordan and Savings(current US$) of Korea (Republic)?
Your answer should be compact. -2.10e+1. In the year 1987, what is the difference between the Savings(current US$) of Guatemala and Savings(current US$) of Japan?
Keep it short and to the point. -4.73e+11. In the year 1987, what is the difference between the Savings(current US$) of Guatemala and Savings(current US$) of Jordan?
Ensure brevity in your answer.  -4.47e+08. In the year 1987, what is the difference between the Savings(current US$) of Guatemala and Savings(current US$) of Korea (Republic)?
Provide a short and direct response. -3.23e+1. In the year 1987, what is the difference between the Savings(current US$) in Japan and Savings(current US$) in Jordan?
Ensure brevity in your answer.  4.72e+11. In the year 1987, what is the difference between the Savings(current US$) in Japan and Savings(current US$) in Korea (Republic)?
Make the answer very short. 4.41e+11. In the year 1987, what is the difference between the Savings(current US$) in Jordan and Savings(current US$) in Korea (Republic)?
Keep it short and to the point. -3.18e+1. In the year 1988, what is the difference between the Savings(current US$) of Guatemala and Savings(current US$) of Japan?
Offer a very short reply. -6.13e+11. In the year 1988, what is the difference between the Savings(current US$) of Guatemala and Savings(current US$) of Jordan?
Make the answer very short. -5.59e+08. In the year 1988, what is the difference between the Savings(current US$) in Guatemala and Savings(current US$) in Korea (Republic)?
Offer a terse response. -4.50e+1. In the year 1988, what is the difference between the Savings(current US$) of Japan and Savings(current US$) of Jordan?
Make the answer very short. 6.12e+11. In the year 1988, what is the difference between the Savings(current US$) in Japan and Savings(current US$) in Korea (Republic)?
Ensure brevity in your answer.  5.68e+11. In the year 1988, what is the difference between the Savings(current US$) of Jordan and Savings(current US$) of Korea (Republic)?
Provide a succinct answer. -4.45e+1. In the year 1989, what is the difference between the Savings(current US$) of Guatemala and Savings(current US$) of Japan?
Offer a terse response. -6.11e+11. In the year 1989, what is the difference between the Savings(current US$) in Guatemala and Savings(current US$) in Jordan?
Offer a terse response. -6.86e+08. In the year 1989, what is the difference between the Savings(current US$) in Guatemala and Savings(current US$) in Korea (Republic)?
Your response must be concise. -5.05e+1. In the year 1989, what is the difference between the Savings(current US$) in Japan and Savings(current US$) in Jordan?
Make the answer very short. 6.10e+11. In the year 1989, what is the difference between the Savings(current US$) in Japan and Savings(current US$) in Korea (Republic)?
Provide a succinct answer. 5.61e+11. In the year 1989, what is the difference between the Savings(current US$) of Jordan and Savings(current US$) of Korea (Republic)?
Your response must be concise. -4.98e+1. In the year 1990, what is the difference between the Savings(current US$) in Guatemala and Savings(current US$) in Japan?
Ensure brevity in your answer.  -6.19e+11. In the year 1990, what is the difference between the Savings(current US$) in Guatemala and Savings(current US$) in Jordan?
Offer a terse response. -5.24e+08. In the year 1990, what is the difference between the Savings(current US$) of Guatemala and Savings(current US$) of Korea (Republic)?
Offer a terse response. -5.89e+1. In the year 1990, what is the difference between the Savings(current US$) of Japan and Savings(current US$) of Jordan?
Make the answer very short. 6.18e+11. In the year 1990, what is the difference between the Savings(current US$) in Japan and Savings(current US$) in Korea (Republic)?
Your response must be concise. 5.60e+11. In the year 1990, what is the difference between the Savings(current US$) in Jordan and Savings(current US$) in Korea (Republic)?
Ensure brevity in your answer.  -5.84e+1. In the year 1991, what is the difference between the Savings(current US$) in Guatemala and Savings(current US$) in Japan?
Provide a succinct answer. -6.83e+11. In the year 1991, what is the difference between the Savings(current US$) in Guatemala and Savings(current US$) in Jordan?
Offer a terse response. 1.34e+07. In the year 1991, what is the difference between the Savings(current US$) of Guatemala and Savings(current US$) of Korea (Republic)?
Provide a succinct answer. -7.26e+1. In the year 1991, what is the difference between the Savings(current US$) of Japan and Savings(current US$) of Jordan?
Provide a short and direct response. 6.83e+11. In the year 1991, what is the difference between the Savings(current US$) in Japan and Savings(current US$) in Korea (Republic)?
Provide a succinct answer. 6.11e+11. In the year 1991, what is the difference between the Savings(current US$) of Jordan and Savings(current US$) of Korea (Republic)?
Provide a short and direct response. -7.26e+1. In the year 1992, what is the difference between the Savings(current US$) of Guatemala and Savings(current US$) of Japan?
Your answer should be very brief. -6.80e+11. In the year 1992, what is the difference between the Savings(current US$) of Guatemala and Savings(current US$) of Jordan?
Your answer should be compact. -2.45e+08. In the year 1992, what is the difference between the Savings(current US$) of Guatemala and Savings(current US$) of Korea (Republic)?
Your answer should be compact. -7.56e+1. In the year 1992, what is the difference between the Savings(current US$) of Japan and Savings(current US$) of Jordan?
Give a very brief answer. 6.80e+11. In the year 1992, what is the difference between the Savings(current US$) of Japan and Savings(current US$) of Korea (Republic)?
Your answer should be compact. 6.05e+11. In the year 1992, what is the difference between the Savings(current US$) of Jordan and Savings(current US$) of Korea (Republic)?
Offer a terse response. -7.53e+1. What is the ratio of the Savings(current US$) of Guatemala in 1985 to that in 1986?
Your response must be concise. 0.92. What is the ratio of the Savings(current US$) in Japan in 1985 to that in 1986?
Offer a terse response. 0.68. What is the ratio of the Savings(current US$) in Jordan in 1985 to that in 1986?
Provide a succinct answer. 0.61. What is the ratio of the Savings(current US$) in Korea (Republic) in 1985 to that in 1986?
Keep it short and to the point. 0.67. What is the ratio of the Savings(current US$) of Guatemala in 1985 to that in 1987?
Give a very brief answer. 2.91. What is the ratio of the Savings(current US$) of Japan in 1985 to that in 1987?
Your response must be concise. 0.57. What is the ratio of the Savings(current US$) in Jordan in 1985 to that in 1987?
Your answer should be very brief. 0.8. What is the ratio of the Savings(current US$) of Korea (Republic) in 1985 to that in 1987?
Keep it short and to the point. 0.45. What is the ratio of the Savings(current US$) in Guatemala in 1985 to that in 1988?
Give a very brief answer. 1.39. What is the ratio of the Savings(current US$) of Japan in 1985 to that in 1988?
Give a very brief answer. 0.44. What is the ratio of the Savings(current US$) of Jordan in 1985 to that in 1988?
Your response must be concise. 0.59. What is the ratio of the Savings(current US$) in Korea (Republic) in 1985 to that in 1988?
Your response must be concise. 0.32. What is the ratio of the Savings(current US$) in Guatemala in 1985 to that in 1989?
Give a very brief answer. 0.86. What is the ratio of the Savings(current US$) of Japan in 1985 to that in 1989?
Ensure brevity in your answer.  0.44. What is the ratio of the Savings(current US$) of Jordan in 1985 to that in 1989?
Your answer should be very brief. 0.45. What is the ratio of the Savings(current US$) of Korea (Republic) in 1985 to that in 1989?
Keep it short and to the point. 0.29. What is the ratio of the Savings(current US$) of Guatemala in 1985 to that in 1990?
Ensure brevity in your answer.  1.44. What is the ratio of the Savings(current US$) in Japan in 1985 to that in 1990?
Provide a succinct answer. 0.44. What is the ratio of the Savings(current US$) in Jordan in 1985 to that in 1990?
Provide a short and direct response. 0.62. What is the ratio of the Savings(current US$) of Korea (Republic) in 1985 to that in 1990?
Your answer should be very brief. 0.25. What is the ratio of the Savings(current US$) in Guatemala in 1985 to that in 1991?
Give a very brief answer. 0.59. What is the ratio of the Savings(current US$) of Japan in 1985 to that in 1991?
Give a very brief answer. 0.4. What is the ratio of the Savings(current US$) of Jordan in 1985 to that in 1991?
Your answer should be compact. 1.19. What is the ratio of the Savings(current US$) of Korea (Republic) in 1985 to that in 1991?
Provide a short and direct response. 0.2. What is the ratio of the Savings(current US$) in Guatemala in 1985 to that in 1992?
Offer a terse response. 0.55. What is the ratio of the Savings(current US$) of Japan in 1985 to that in 1992?
Your response must be concise. 0.4. What is the ratio of the Savings(current US$) of Jordan in 1985 to that in 1992?
Offer a very short reply. 0.65. What is the ratio of the Savings(current US$) of Korea (Republic) in 1985 to that in 1992?
Provide a short and direct response. 0.19. What is the ratio of the Savings(current US$) of Guatemala in 1986 to that in 1987?
Provide a short and direct response. 3.17. What is the ratio of the Savings(current US$) of Japan in 1986 to that in 1987?
Provide a succinct answer. 0.85. What is the ratio of the Savings(current US$) in Jordan in 1986 to that in 1987?
Provide a succinct answer. 1.32. What is the ratio of the Savings(current US$) in Korea (Republic) in 1986 to that in 1987?
Offer a terse response. 0.67. What is the ratio of the Savings(current US$) in Guatemala in 1986 to that in 1988?
Offer a very short reply. 1.52. What is the ratio of the Savings(current US$) of Japan in 1986 to that in 1988?
Provide a short and direct response. 0.66. What is the ratio of the Savings(current US$) in Jordan in 1986 to that in 1988?
Give a very brief answer. 0.96. What is the ratio of the Savings(current US$) of Korea (Republic) in 1986 to that in 1988?
Give a very brief answer. 0.48. What is the ratio of the Savings(current US$) in Guatemala in 1986 to that in 1989?
Your answer should be very brief. 0.93. What is the ratio of the Savings(current US$) of Japan in 1986 to that in 1989?
Your response must be concise. 0.66. What is the ratio of the Savings(current US$) in Jordan in 1986 to that in 1989?
Keep it short and to the point. 0.73. What is the ratio of the Savings(current US$) in Korea (Republic) in 1986 to that in 1989?
Your answer should be compact. 0.43. What is the ratio of the Savings(current US$) of Guatemala in 1986 to that in 1990?
Keep it short and to the point. 1.57. What is the ratio of the Savings(current US$) in Japan in 1986 to that in 1990?
Make the answer very short. 0.65. What is the ratio of the Savings(current US$) in Jordan in 1986 to that in 1990?
Offer a terse response. 1.02. What is the ratio of the Savings(current US$) in Korea (Republic) in 1986 to that in 1990?
Offer a terse response. 0.37. What is the ratio of the Savings(current US$) in Guatemala in 1986 to that in 1991?
Offer a terse response. 0.65. What is the ratio of the Savings(current US$) of Japan in 1986 to that in 1991?
Make the answer very short. 0.59. What is the ratio of the Savings(current US$) of Jordan in 1986 to that in 1991?
Offer a very short reply. 1.96. What is the ratio of the Savings(current US$) in Korea (Republic) in 1986 to that in 1991?
Provide a short and direct response. 0.3. What is the ratio of the Savings(current US$) of Guatemala in 1986 to that in 1992?
Your answer should be compact. 0.59. What is the ratio of the Savings(current US$) of Japan in 1986 to that in 1992?
Provide a succinct answer. 0.59. What is the ratio of the Savings(current US$) of Jordan in 1986 to that in 1992?
Your answer should be compact. 1.07. What is the ratio of the Savings(current US$) of Korea (Republic) in 1986 to that in 1992?
Your answer should be very brief. 0.29. What is the ratio of the Savings(current US$) in Guatemala in 1987 to that in 1988?
Offer a very short reply. 0.48. What is the ratio of the Savings(current US$) in Japan in 1987 to that in 1988?
Offer a very short reply. 0.77. What is the ratio of the Savings(current US$) of Jordan in 1987 to that in 1988?
Offer a very short reply. 0.73. What is the ratio of the Savings(current US$) of Korea (Republic) in 1987 to that in 1988?
Your answer should be compact. 0.72. What is the ratio of the Savings(current US$) of Guatemala in 1987 to that in 1989?
Provide a short and direct response. 0.3. What is the ratio of the Savings(current US$) in Japan in 1987 to that in 1989?
Ensure brevity in your answer.  0.77. What is the ratio of the Savings(current US$) of Jordan in 1987 to that in 1989?
Give a very brief answer. 0.56. What is the ratio of the Savings(current US$) in Korea (Republic) in 1987 to that in 1989?
Give a very brief answer. 0.64. What is the ratio of the Savings(current US$) in Guatemala in 1987 to that in 1990?
Provide a short and direct response. 0.49. What is the ratio of the Savings(current US$) of Japan in 1987 to that in 1990?
Your answer should be very brief. 0.76. What is the ratio of the Savings(current US$) in Jordan in 1987 to that in 1990?
Ensure brevity in your answer.  0.77. What is the ratio of the Savings(current US$) in Korea (Republic) in 1987 to that in 1990?
Your answer should be compact. 0.55. What is the ratio of the Savings(current US$) of Guatemala in 1987 to that in 1991?
Offer a terse response. 0.2. What is the ratio of the Savings(current US$) in Japan in 1987 to that in 1991?
Ensure brevity in your answer.  0.69. What is the ratio of the Savings(current US$) in Jordan in 1987 to that in 1991?
Your response must be concise. 1.48. What is the ratio of the Savings(current US$) in Korea (Republic) in 1987 to that in 1991?
Give a very brief answer. 0.44. What is the ratio of the Savings(current US$) in Guatemala in 1987 to that in 1992?
Ensure brevity in your answer.  0.19. What is the ratio of the Savings(current US$) of Japan in 1987 to that in 1992?
Offer a very short reply. 0.69. What is the ratio of the Savings(current US$) of Jordan in 1987 to that in 1992?
Your answer should be compact. 0.81. What is the ratio of the Savings(current US$) in Korea (Republic) in 1987 to that in 1992?
Offer a terse response. 0.43. What is the ratio of the Savings(current US$) of Guatemala in 1988 to that in 1989?
Offer a very short reply. 0.62. What is the ratio of the Savings(current US$) in Japan in 1988 to that in 1989?
Make the answer very short. 1. What is the ratio of the Savings(current US$) of Jordan in 1988 to that in 1989?
Give a very brief answer. 0.76. What is the ratio of the Savings(current US$) in Korea (Republic) in 1988 to that in 1989?
Make the answer very short. 0.89. What is the ratio of the Savings(current US$) in Guatemala in 1988 to that in 1990?
Offer a very short reply. 1.03. What is the ratio of the Savings(current US$) in Japan in 1988 to that in 1990?
Give a very brief answer. 0.99. What is the ratio of the Savings(current US$) in Jordan in 1988 to that in 1990?
Give a very brief answer. 1.06. What is the ratio of the Savings(current US$) of Korea (Republic) in 1988 to that in 1990?
Make the answer very short. 0.76. What is the ratio of the Savings(current US$) in Guatemala in 1988 to that in 1991?
Your answer should be compact. 0.43. What is the ratio of the Savings(current US$) of Japan in 1988 to that in 1991?
Your answer should be very brief. 0.9. What is the ratio of the Savings(current US$) in Jordan in 1988 to that in 1991?
Offer a terse response. 2.03. What is the ratio of the Savings(current US$) of Korea (Republic) in 1988 to that in 1991?
Ensure brevity in your answer.  0.62. What is the ratio of the Savings(current US$) in Guatemala in 1988 to that in 1992?
Keep it short and to the point. 0.39. What is the ratio of the Savings(current US$) in Japan in 1988 to that in 1992?
Your answer should be very brief. 0.9. What is the ratio of the Savings(current US$) in Jordan in 1988 to that in 1992?
Provide a succinct answer. 1.11. What is the ratio of the Savings(current US$) in Korea (Republic) in 1988 to that in 1992?
Give a very brief answer. 0.59. What is the ratio of the Savings(current US$) in Guatemala in 1989 to that in 1990?
Give a very brief answer. 1.68. What is the ratio of the Savings(current US$) of Jordan in 1989 to that in 1990?
Your answer should be compact. 1.39. What is the ratio of the Savings(current US$) of Korea (Republic) in 1989 to that in 1990?
Provide a short and direct response. 0.86. What is the ratio of the Savings(current US$) in Guatemala in 1989 to that in 1991?
Your response must be concise. 0.69. What is the ratio of the Savings(current US$) in Japan in 1989 to that in 1991?
Provide a short and direct response. 0.89. What is the ratio of the Savings(current US$) of Jordan in 1989 to that in 1991?
Provide a succinct answer. 2.66. What is the ratio of the Savings(current US$) of Korea (Republic) in 1989 to that in 1991?
Your answer should be compact. 0.7. What is the ratio of the Savings(current US$) in Guatemala in 1989 to that in 1992?
Offer a terse response. 0.64. What is the ratio of the Savings(current US$) of Japan in 1989 to that in 1992?
Offer a very short reply. 0.9. What is the ratio of the Savings(current US$) in Jordan in 1989 to that in 1992?
Make the answer very short. 1.46. What is the ratio of the Savings(current US$) of Korea (Republic) in 1989 to that in 1992?
Give a very brief answer. 0.67. What is the ratio of the Savings(current US$) of Guatemala in 1990 to that in 1991?
Offer a terse response. 0.41. What is the ratio of the Savings(current US$) of Japan in 1990 to that in 1991?
Your answer should be very brief. 0.91. What is the ratio of the Savings(current US$) of Jordan in 1990 to that in 1991?
Provide a short and direct response. 1.91. What is the ratio of the Savings(current US$) of Korea (Republic) in 1990 to that in 1991?
Offer a terse response. 0.81. What is the ratio of the Savings(current US$) of Guatemala in 1990 to that in 1992?
Give a very brief answer. 0.38. What is the ratio of the Savings(current US$) in Japan in 1990 to that in 1992?
Offer a very short reply. 0.91. What is the ratio of the Savings(current US$) of Jordan in 1990 to that in 1992?
Provide a succinct answer. 1.05. What is the ratio of the Savings(current US$) in Korea (Republic) in 1990 to that in 1992?
Offer a terse response. 0.78. What is the ratio of the Savings(current US$) of Guatemala in 1991 to that in 1992?
Your response must be concise. 0.92. What is the ratio of the Savings(current US$) of Japan in 1991 to that in 1992?
Offer a terse response. 1. What is the ratio of the Savings(current US$) of Jordan in 1991 to that in 1992?
Keep it short and to the point. 0.55. What is the ratio of the Savings(current US$) in Korea (Republic) in 1991 to that in 1992?
Your response must be concise. 0.96. What is the difference between the highest and the second highest Savings(current US$) of Guatemala?
Keep it short and to the point. 3.26e+07. What is the difference between the highest and the second highest Savings(current US$) of Japan?
Give a very brief answer. 2.75e+09. What is the difference between the highest and the second highest Savings(current US$) of Jordan?
Give a very brief answer. 2.24e+08. What is the difference between the highest and the second highest Savings(current US$) of Korea (Republic)?
Keep it short and to the point. 3.00e+09. What is the difference between the highest and the lowest Savings(current US$) in Guatemala?
Give a very brief answer. 3.24e+08. What is the difference between the highest and the lowest Savings(current US$) of Japan?
Provide a short and direct response. 4.12e+11. What is the difference between the highest and the lowest Savings(current US$) in Jordan?
Offer a terse response. 5.87e+08. What is the difference between the highest and the lowest Savings(current US$) in Korea (Republic)?
Keep it short and to the point. 6.14e+1. 